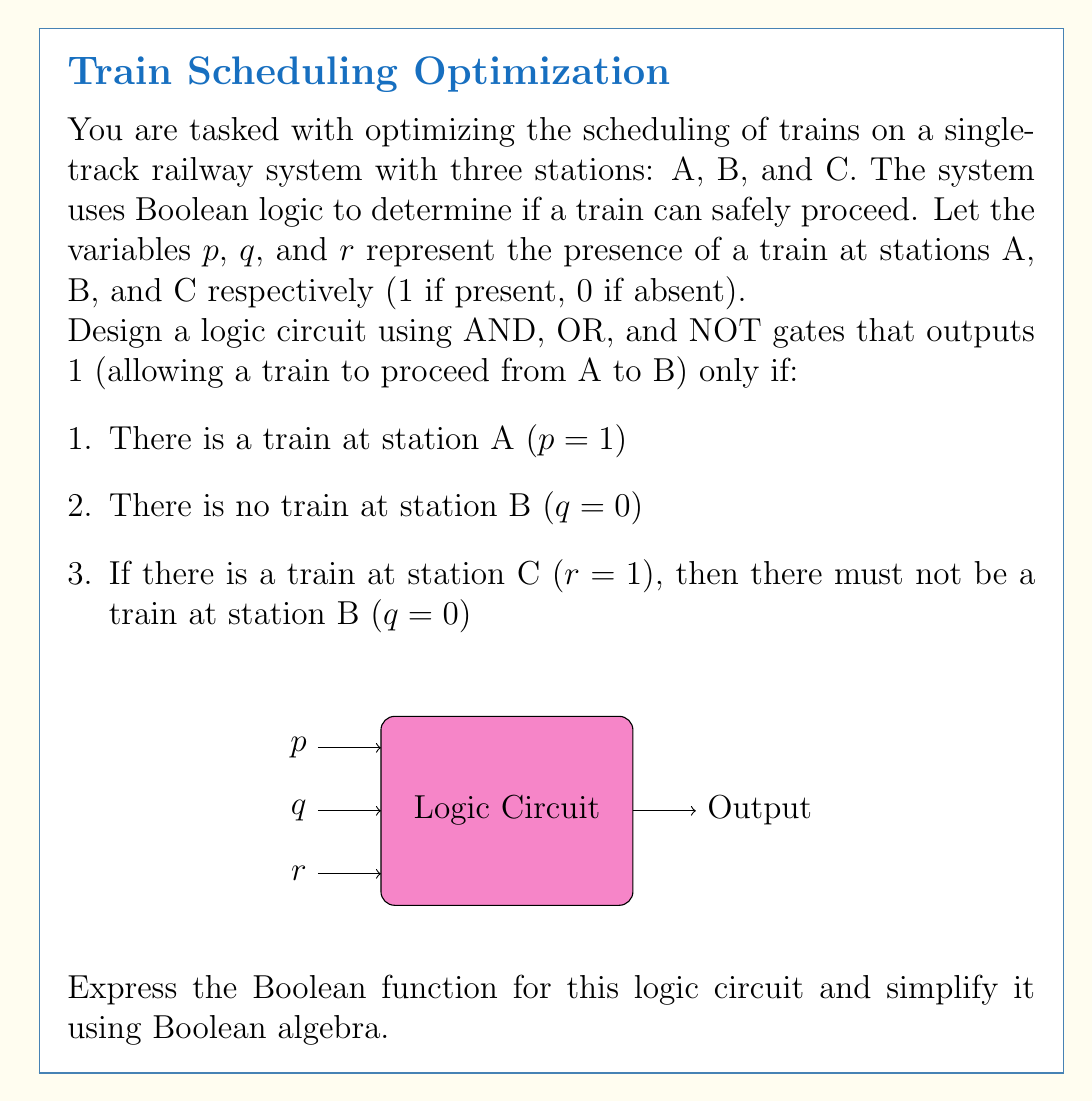Solve this math problem. Let's approach this step-by-step:

1) First, we need to translate the conditions into Boolean expressions:
   - Condition 1: $p$
   - Condition 2: $\neg q$
   - Condition 3: $r \rightarrow \neg q$, which is equivalent to $\neg r \lor \neg q$

2) The overall function should be the AND of these conditions:
   $f(p,q,r) = p \land \neg q \land (\neg r \lor \neg q)$

3) Let's simplify this using Boolean algebra:
   $f(p,q,r) = p \land \neg q \land (\neg r \lor \neg q)$
             $= p \land \neg q \land \neg q \lor p \land \neg q \land \neg r$
             $= p \land \neg q \land \neg q \lor p \land \neg q \land \neg r$
             $= p \land \neg q \lor p \land \neg q \land \neg r$
             $= p \land \neg q \land (1 \lor \neg r)$
             $= p \land \neg q$

4) The simplified Boolean function is $f(p,q,r) = p \land \neg q$

5) This can be implemented with an AND gate and a NOT gate:
   - Input $p$ goes directly into the AND gate
   - Input $q$ goes through a NOT gate and then into the AND gate
   - Input $r$ is not needed in the final simplified circuit

[asy]
unitsize(30);
draw((-1,2)--(0,2));
draw((-1,1)--(0,1));
label("$p$", (-1.2,2));
label("$q$", (-1.2,1));
draw((0,1)--(1,1));
draw((1,0.8)--(1,1.2));
draw((1,1)--(2,1));
draw((2,0.8)--(2,1.2)--(2.2,1)--cycle);
label("NOT", (1.5,0.5));
draw((0,2)--(3,2));
draw((3,1.8)--(3,2.2)--(3.2,2)--cycle);
draw((3,1)--(3,2));
label("AND", (3,1.5));
draw((3.2,2)--(4,2));
label("Output", (4.2,2));
[/asy]
Answer: $f(p,q,r) = p \land \neg q$ 